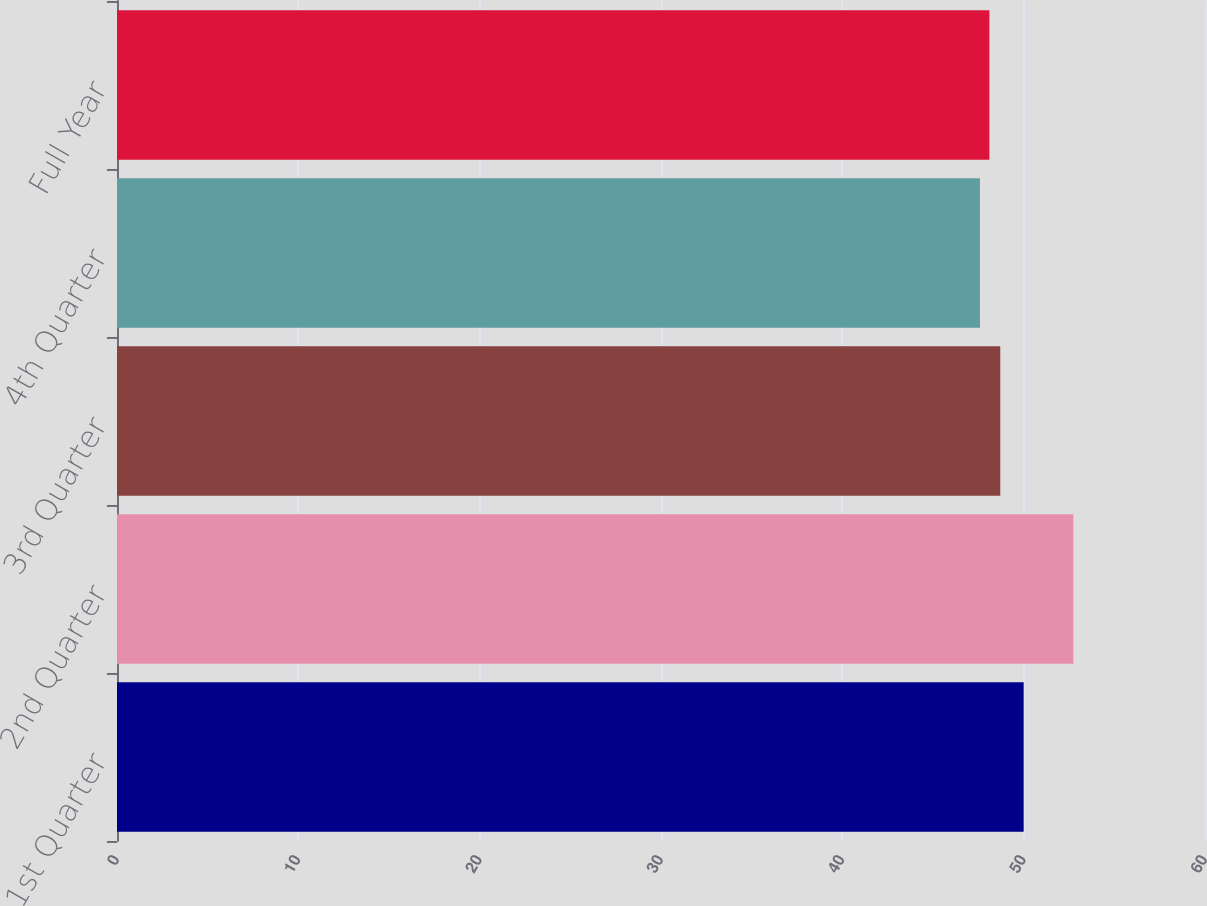Convert chart. <chart><loc_0><loc_0><loc_500><loc_500><bar_chart><fcel>1st Quarter<fcel>2nd Quarter<fcel>3rd Quarter<fcel>4th Quarter<fcel>Full Year<nl><fcel>50<fcel>52.74<fcel>48.71<fcel>47.59<fcel>48.11<nl></chart> 